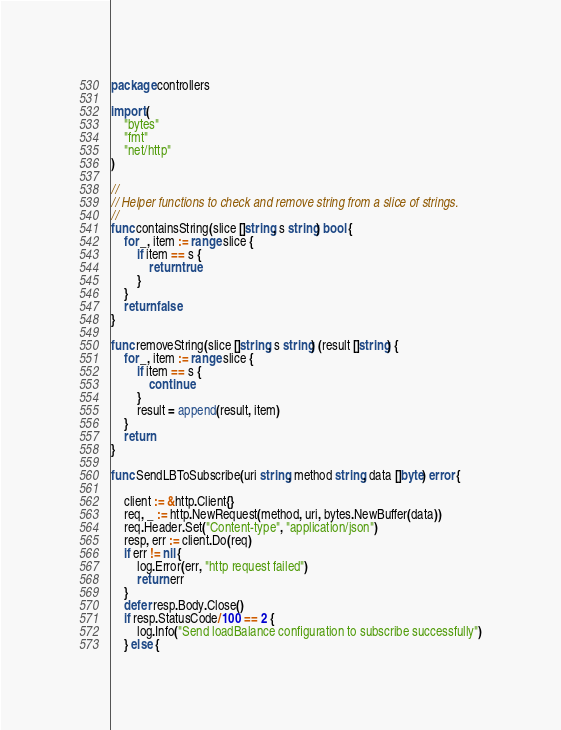Convert code to text. <code><loc_0><loc_0><loc_500><loc_500><_Go_>package controllers

import (
	"bytes"
	"fmt"
	"net/http"
)

//
// Helper functions to check and remove string from a slice of strings.
//
func containsString(slice []string, s string) bool {
	for _, item := range slice {
		if item == s {
			return true
		}
	}
	return false
}

func removeString(slice []string, s string) (result []string) {
	for _, item := range slice {
		if item == s {
			continue
		}
		result = append(result, item)
	}
	return
}

func SendLBToSubscribe(uri string, method string, data []byte) error {

	client := &http.Client{}
	req, _ := http.NewRequest(method, uri, bytes.NewBuffer(data))
	req.Header.Set("Content-type", "application/json")
	resp, err := client.Do(req)
	if err != nil {
		log.Error(err, "http request failed")
		return err
	}
	defer resp.Body.Close()
	if resp.StatusCode/100 == 2 {
		log.Info("Send loadBalance configuration to subscribe successfully")
	} else {</code> 